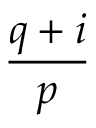<formula> <loc_0><loc_0><loc_500><loc_500>\frac { q + i } { p }</formula> 